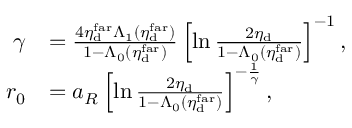Convert formula to latex. <formula><loc_0><loc_0><loc_500><loc_500>\begin{array} { r l } { \gamma } & { = \frac { 4 \eta _ { d } ^ { f a r } \Lambda _ { 1 } ( \eta _ { d } ^ { f a r } ) } { 1 - \Lambda _ { 0 } ( \eta _ { d } ^ { f a r } ) } \left [ \ln \frac { 2 \eta _ { d } } { 1 - \Lambda _ { 0 } ( \eta _ { d } ^ { f a r } ) } \right ] ^ { - 1 } , } \\ { r _ { 0 } } & { = a _ { R } \left [ \ln \frac { 2 \eta _ { d } } { 1 - \Lambda _ { 0 } ( \eta _ { d } ^ { f a r } ) } \right ] ^ { - \frac { 1 } { \gamma } } , } \end{array}</formula> 